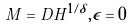Convert formula to latex. <formula><loc_0><loc_0><loc_500><loc_500>M = D H ^ { 1 / \delta } , { \epsilon } = 0 \,</formula> 